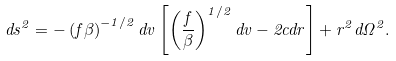<formula> <loc_0><loc_0><loc_500><loc_500>d s ^ { 2 } = - \left ( f \beta \right ) ^ { - 1 / 2 } d v \left [ \left ( \frac { f } { \beta } \right ) ^ { 1 / 2 } d v - 2 c d r \right ] + r ^ { 2 } d \Omega ^ { 2 } .</formula> 